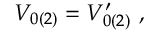<formula> <loc_0><loc_0><loc_500><loc_500>\begin{array} { r } { V _ { 0 ( 2 ) } = V _ { 0 ( 2 ) } ^ { \prime } , } \end{array}</formula> 